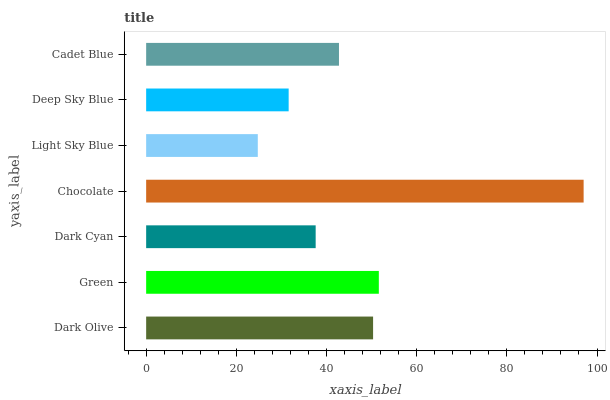Is Light Sky Blue the minimum?
Answer yes or no. Yes. Is Chocolate the maximum?
Answer yes or no. Yes. Is Green the minimum?
Answer yes or no. No. Is Green the maximum?
Answer yes or no. No. Is Green greater than Dark Olive?
Answer yes or no. Yes. Is Dark Olive less than Green?
Answer yes or no. Yes. Is Dark Olive greater than Green?
Answer yes or no. No. Is Green less than Dark Olive?
Answer yes or no. No. Is Cadet Blue the high median?
Answer yes or no. Yes. Is Cadet Blue the low median?
Answer yes or no. Yes. Is Chocolate the high median?
Answer yes or no. No. Is Dark Olive the low median?
Answer yes or no. No. 